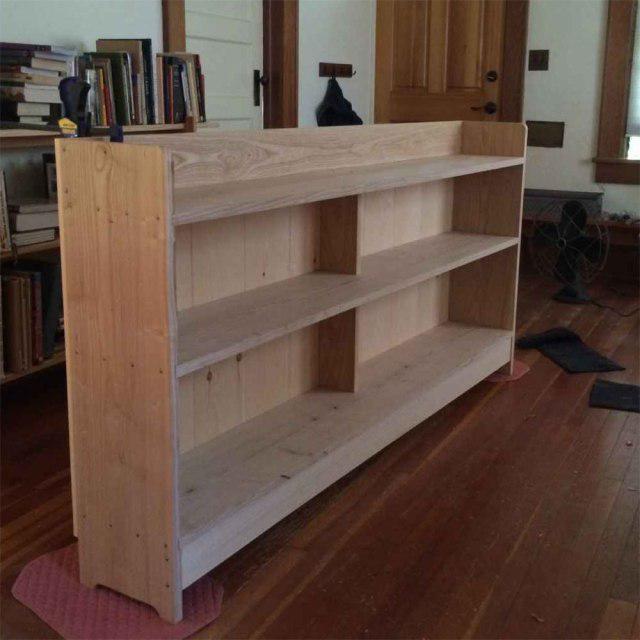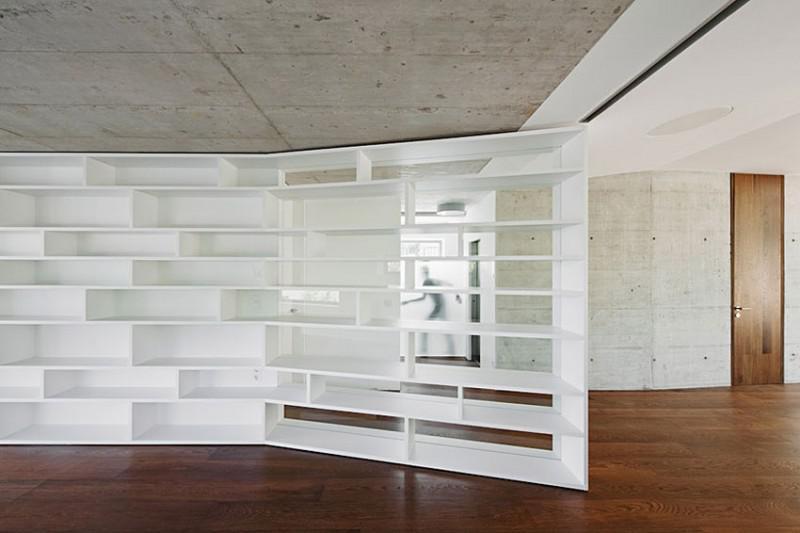The first image is the image on the left, the second image is the image on the right. Examine the images to the left and right. Is the description "All of the bookshelves are empty." accurate? Answer yes or no. Yes. 